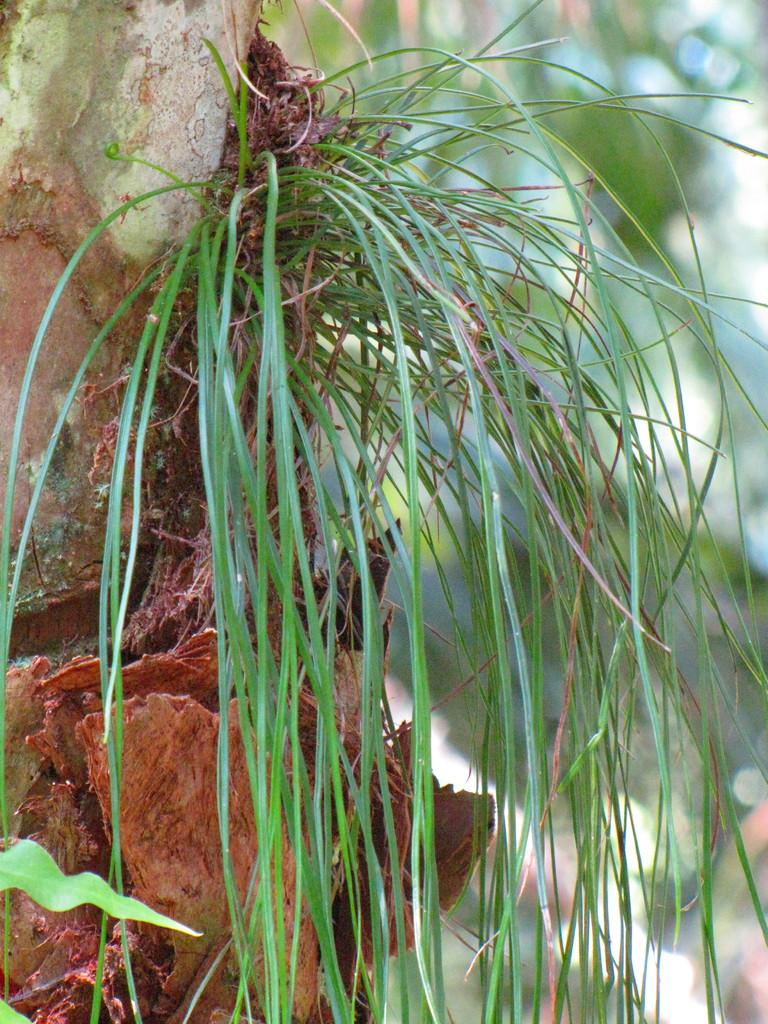What is present in the image? There is a plant in the image. Can you describe the plant in the image? The provided facts do not give specific details about the plant, so we cannot describe it further. What type of environment might the plant be in? The image does not provide enough context to determine the environment of the plant. What type of powder is being used to make the plant sneeze in the image? There is no indication in the image that the plant is sneezing or that any powder is being used. 